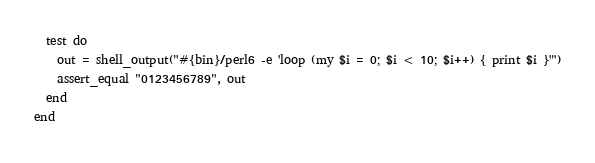Convert code to text. <code><loc_0><loc_0><loc_500><loc_500><_Ruby_>
  test do
    out = shell_output("#{bin}/perl6 -e 'loop (my $i = 0; $i < 10; $i++) { print $i }'")
    assert_equal "0123456789", out
  end
end
</code> 